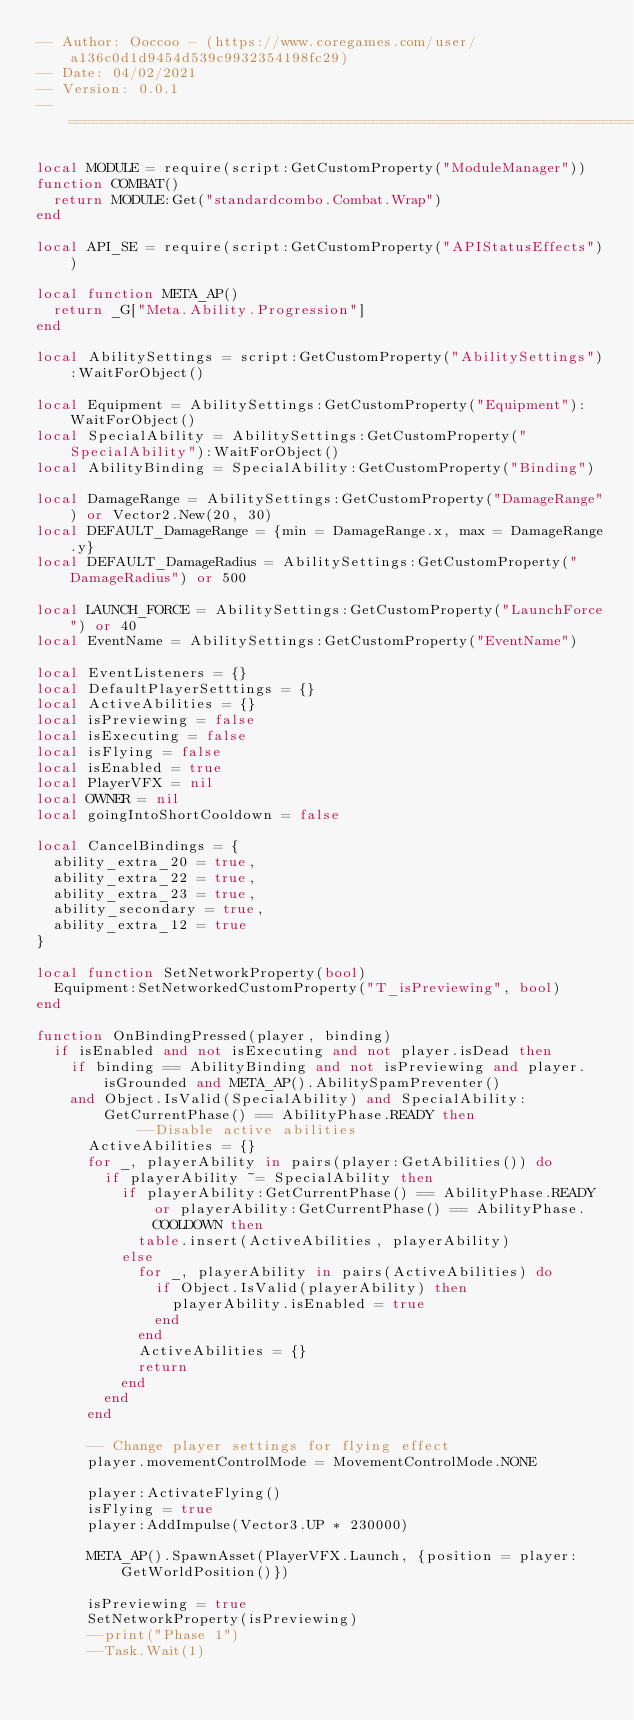Convert code to text. <code><loc_0><loc_0><loc_500><loc_500><_Lua_>-- Author: Ooccoo - (https://www.coregames.com/user/a136c0d1d9454d539c9932354198fc29)
-- Date: 04/02/2021
-- Version: 0.0.1
--===========================================================================================

local MODULE = require(script:GetCustomProperty("ModuleManager"))
function COMBAT()
	return MODULE:Get("standardcombo.Combat.Wrap")
end

local API_SE = require(script:GetCustomProperty("APIStatusEffects"))

local function META_AP()
	return _G["Meta.Ability.Progression"]
end

local AbilitySettings = script:GetCustomProperty("AbilitySettings"):WaitForObject()

local Equipment = AbilitySettings:GetCustomProperty("Equipment"):WaitForObject()
local SpecialAbility = AbilitySettings:GetCustomProperty("SpecialAbility"):WaitForObject()
local AbilityBinding = SpecialAbility:GetCustomProperty("Binding")

local DamageRange = AbilitySettings:GetCustomProperty("DamageRange") or Vector2.New(20, 30)
local DEFAULT_DamageRange = {min = DamageRange.x, max = DamageRange.y}
local DEFAULT_DamageRadius = AbilitySettings:GetCustomProperty("DamageRadius") or 500

local LAUNCH_FORCE = AbilitySettings:GetCustomProperty("LaunchForce") or 40
local EventName = AbilitySettings:GetCustomProperty("EventName")

local EventListeners = {}
local DefaultPlayerSetttings = {}
local ActiveAbilities = {}
local isPreviewing = false
local isExecuting = false
local isFlying = false
local isEnabled = true
local PlayerVFX = nil
local OWNER = nil
local goingIntoShortCooldown = false

local CancelBindings = {
	ability_extra_20 = true,
	ability_extra_22 = true,
	ability_extra_23 = true,
	ability_secondary = true,
	ability_extra_12 = true
}

local function SetNetworkProperty(bool)
	Equipment:SetNetworkedCustomProperty("T_isPreviewing", bool)
end

function OnBindingPressed(player, binding)
	if isEnabled and not isExecuting and not player.isDead then
		if binding == AbilityBinding and not isPreviewing and player.isGrounded and META_AP().AbilitySpamPreventer() 
		and Object.IsValid(SpecialAbility) and SpecialAbility:GetCurrentPhase() == AbilityPhase.READY then
            --Disable active abilities
			ActiveAbilities = {}
			for _, playerAbility in pairs(player:GetAbilities()) do
				if playerAbility ~= SpecialAbility then
					if playerAbility:GetCurrentPhase() == AbilityPhase.READY or playerAbility:GetCurrentPhase() == AbilityPhase.COOLDOWN then
						table.insert(ActiveAbilities, playerAbility)
					else
						for _, playerAbility in pairs(ActiveAbilities) do
							if Object.IsValid(playerAbility) then
								playerAbility.isEnabled = true
							end
						end
						ActiveAbilities = {}
						return
					end
				end
			end

			-- Change player settings for flying effect
			player.movementControlMode = MovementControlMode.NONE
            
			player:ActivateFlying()
			isFlying = true
			player:AddImpulse(Vector3.UP * 230000)

			META_AP().SpawnAsset(PlayerVFX.Launch, {position = player:GetWorldPosition()})

			isPreviewing = true
			SetNetworkProperty(isPreviewing)
			--print("Phase 1")
			--Task.Wait(1)
</code> 